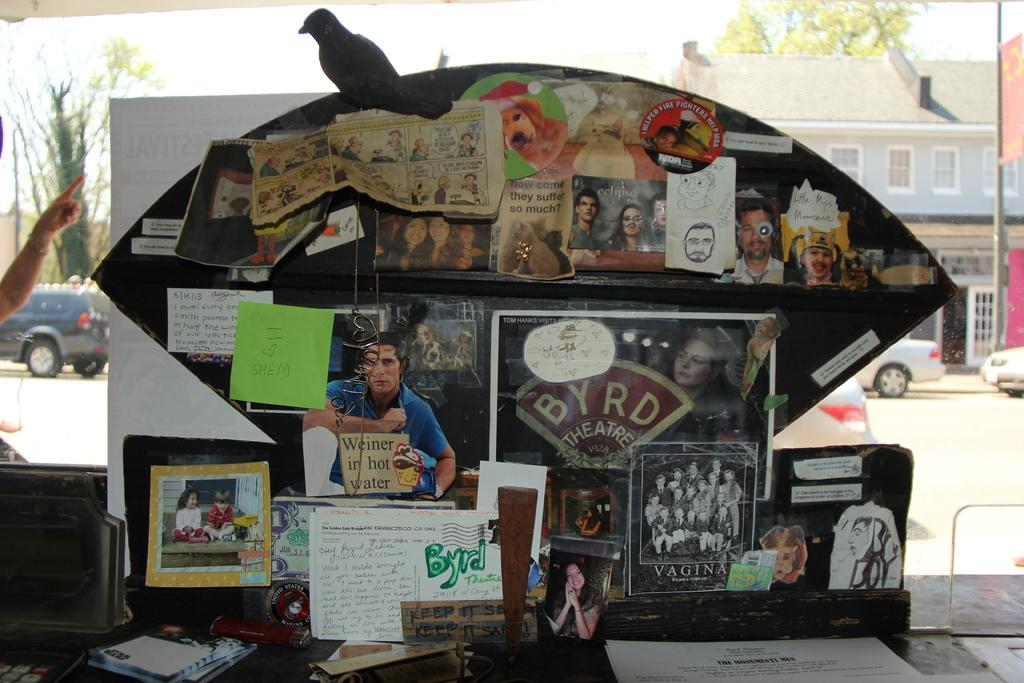What is the main object in the image? There is a board in the image. What is attached to the board? Papers and photographs are present on the board. What can be seen in the background of the image? There is a building and the sky visible in the background of the image. How does the sister feel about the committee in the image? There is no mention of a sister or a committee in the image, so it is not possible to answer that question. 